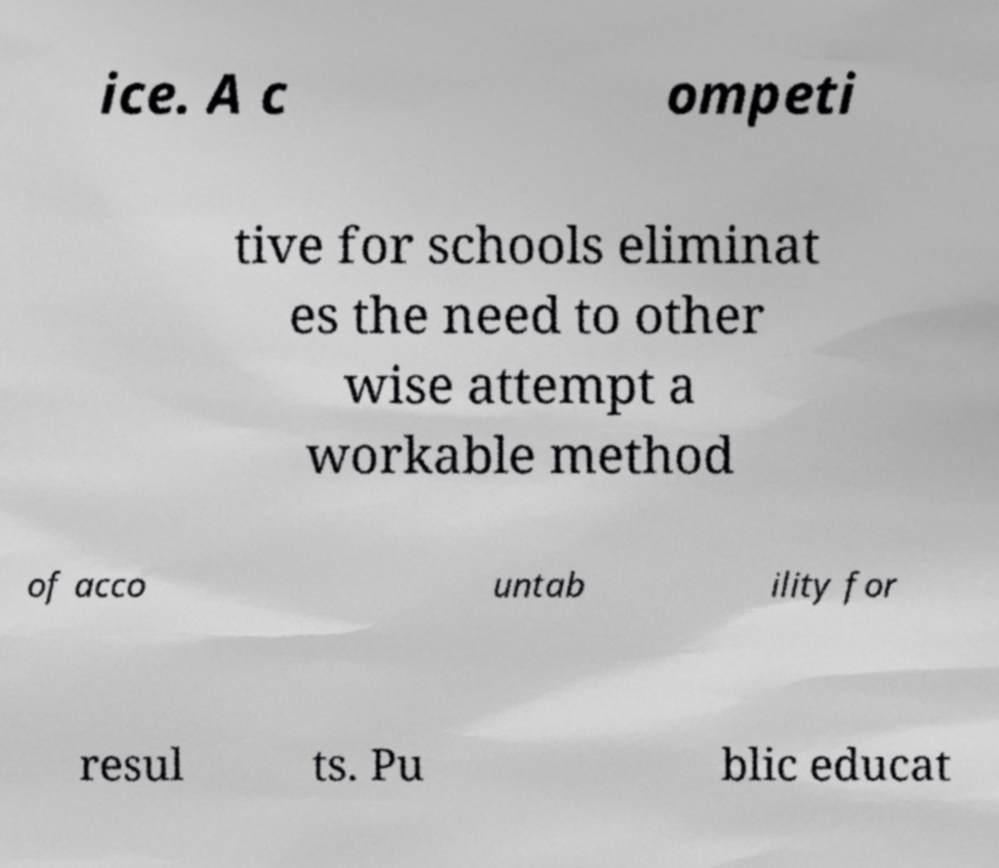Please read and relay the text visible in this image. What does it say? ice. A c ompeti tive for schools eliminat es the need to other wise attempt a workable method of acco untab ility for resul ts. Pu blic educat 